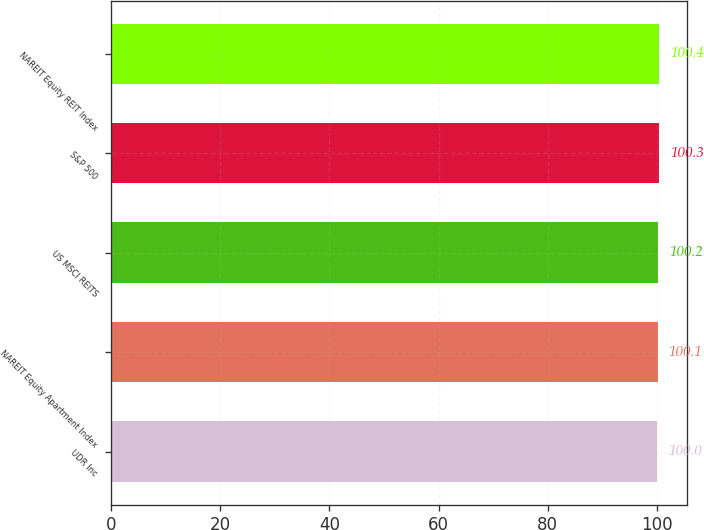<chart> <loc_0><loc_0><loc_500><loc_500><bar_chart><fcel>UDR Inc<fcel>NAREIT Equity Apartment Index<fcel>US MSCI REITS<fcel>S&P 500<fcel>NAREIT Equity REIT Index<nl><fcel>100<fcel>100.1<fcel>100.2<fcel>100.3<fcel>100.4<nl></chart> 